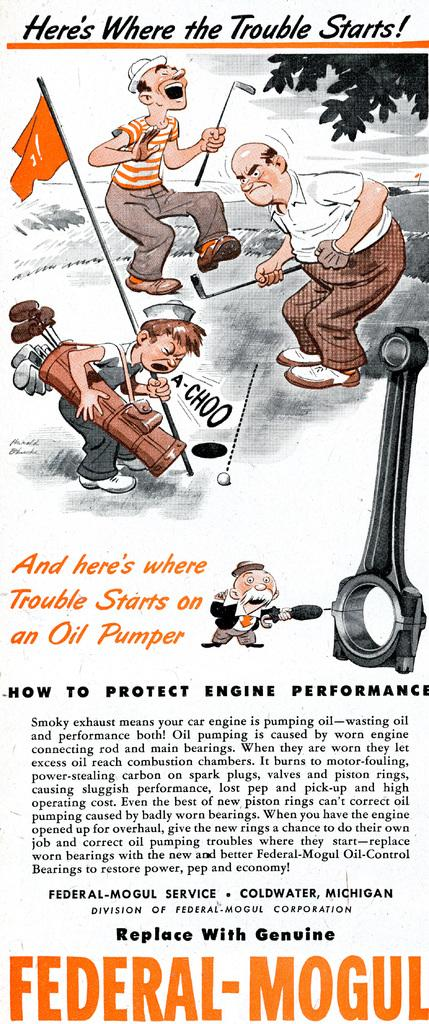What type of content is present in the image? There is an article in the image. What is featured within the article? The article contains a cartoon. Is there any additional information provided about the cartoon? Yes, there is a description about the cartoon in the article. What type of riddle is being solved by the characters in the cartoon? There is no riddle present in the image; the article contains a cartoon with a description, but no riddle is mentioned. 